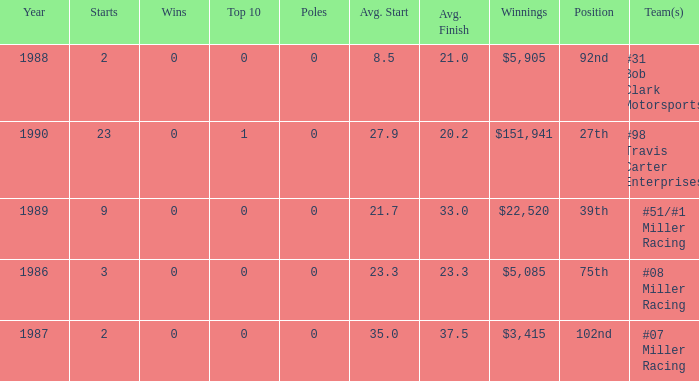What are the poles is #08 Miller racing? 0.0. 